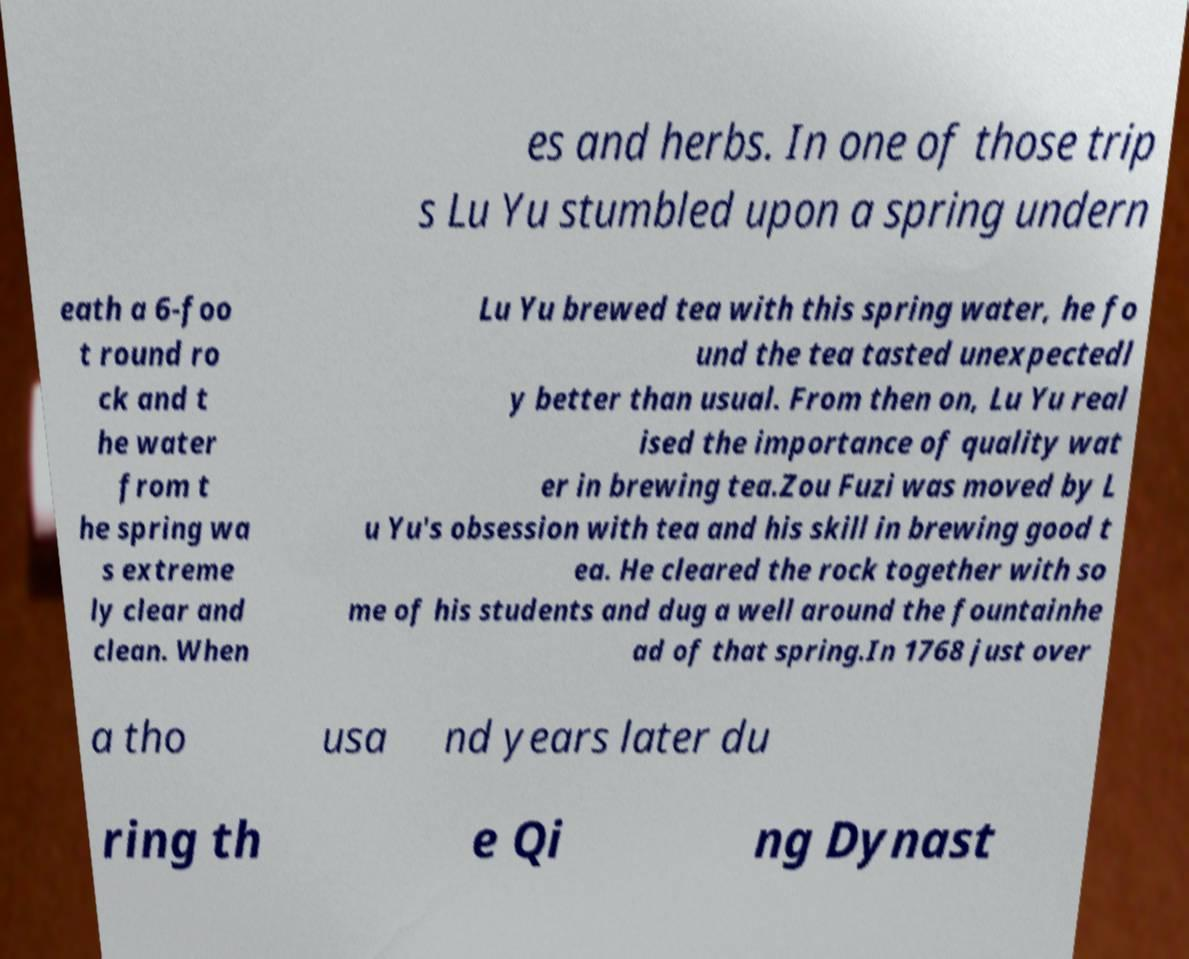Can you read and provide the text displayed in the image?This photo seems to have some interesting text. Can you extract and type it out for me? es and herbs. In one of those trip s Lu Yu stumbled upon a spring undern eath a 6-foo t round ro ck and t he water from t he spring wa s extreme ly clear and clean. When Lu Yu brewed tea with this spring water, he fo und the tea tasted unexpectedl y better than usual. From then on, Lu Yu real ised the importance of quality wat er in brewing tea.Zou Fuzi was moved by L u Yu's obsession with tea and his skill in brewing good t ea. He cleared the rock together with so me of his students and dug a well around the fountainhe ad of that spring.In 1768 just over a tho usa nd years later du ring th e Qi ng Dynast 